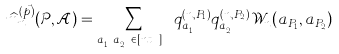<formula> <loc_0><loc_0><loc_500><loc_500>\widehat { m } _ { n } ^ { ( \vec { p } ) } ( \mathcal { P } , \mathcal { A } ) = \sum _ { a _ { P _ { 1 } } \neq a _ { P _ { 2 } } \in [ n t _ { N } ] } q _ { a _ { P _ { 1 } } } ^ { ( n , P _ { 1 } ) } q _ { a _ { P _ { 2 } } } ^ { ( n , P _ { 2 } ) } \mathcal { W } _ { n } ( a _ { P _ { 1 } } , a _ { P _ { 2 } } )</formula> 